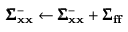Convert formula to latex. <formula><loc_0><loc_0><loc_500><loc_500>\pm b { \Sigma } _ { x x } ^ { - } \leftarrow \pm b { \Sigma } _ { x x } ^ { - } + \pm b { \Sigma } _ { f f }</formula> 